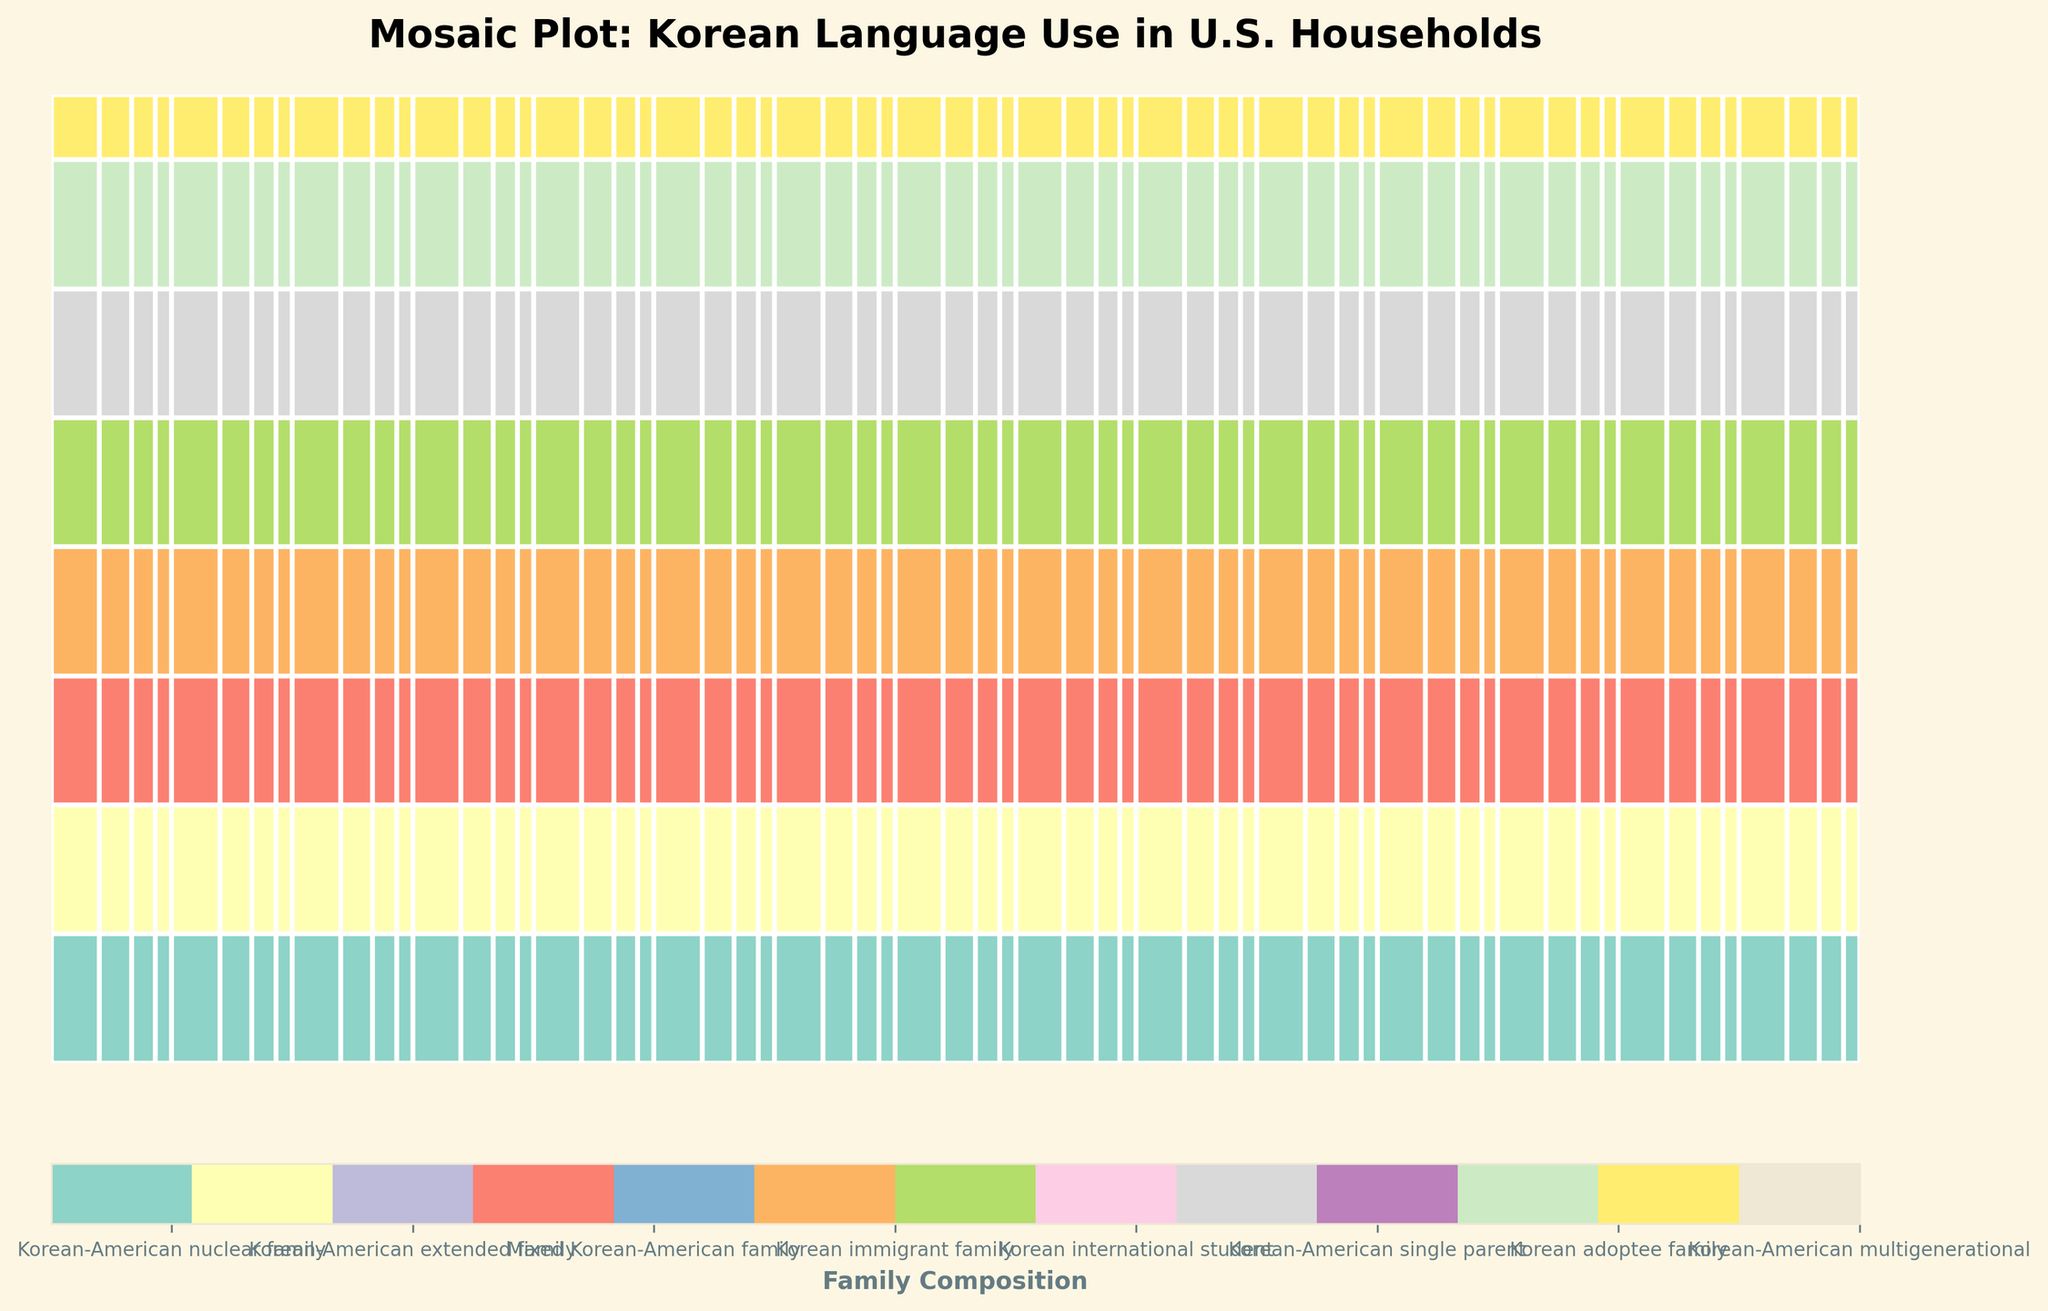What is the title of the plot? The title is typically located at the top of the figure in larger or bold font. It provides a summary of the data being visualized. The title in this case is "Mosaic Plot: Korean Language Use in U.S. Households."
Answer: Mosaic Plot: Korean Language Use in U.S. Households Which frequency of Korean language use appears most frequently in the plot? By looking at how the rectangles are colored and labeled, the frequency of "Daily" should be visually the most prevalent. The largest portion of the rectangles represents "Daily" use.
Answer: Daily How many different family compositions are represented in the plot? The legend at the bottom, which shows the different colors, allows us to count the distinct family compositions. Each unique color corresponds to a different family composition.
Answer: 8 Which geographic location has the highest proportion of families that use Korean daily? By examining the width of rectangles corresponding to "Daily" frequency across different geographic locations, we identify that the location with the widest rectangles in this category represents the highest proportion.
Answer: Washington What combination of family composition and geographic location use Korean rarely? In the plot, locate the "Rarely" section and observe which family compositions and geographic locations fall within this category. There are likely added labels in the rectangles.
Answer: Korean adoptee family in Minnesota and Pennsylvania Are there any family compositions that don't use Korean monthly? To determine this, check each family composition label and find if any of them lack labels under the "Monthly" frequency category.
Answer: Korean-American extended family, Korean immigrant family, Korean international student, Korean adoptee family, and Korean-American multigenerational Of the families that use Korean weekly, which family composition appears most frequently? Look at the size of the rectangles in the "Weekly" frequency category for each family composition. The composition with the largest rectangle here is the most frequent.
Answer: Korean-American extended family Compare the frequency of Korean use between Korean-American nuclear families and Korean international students. Which one has a higher proportion of daily use? Compare the "Daily" sections for both family compositions; the one with larger colored rectangles or more area covered indicates higher daily use.
Answer: Korean international students If you combine the "Daily" users in California, Washington, and New Jersey, do they represent a majority of the daily users in this dataset? Examine the proportions of daily users in each state, and summing their areas should be compared to the total area of "Daily" users in the entire plot.
Answer: Yes What can you infer about the diversity of Korean language use in mixed Korean-American families across different states? By evaluating the different shades and sizes of rectangles under mixed Korean-American families across various states, we note that these families appear in almost every frequency category, indicating a diverse range of language use.
Answer: Diverse across all frequencies 